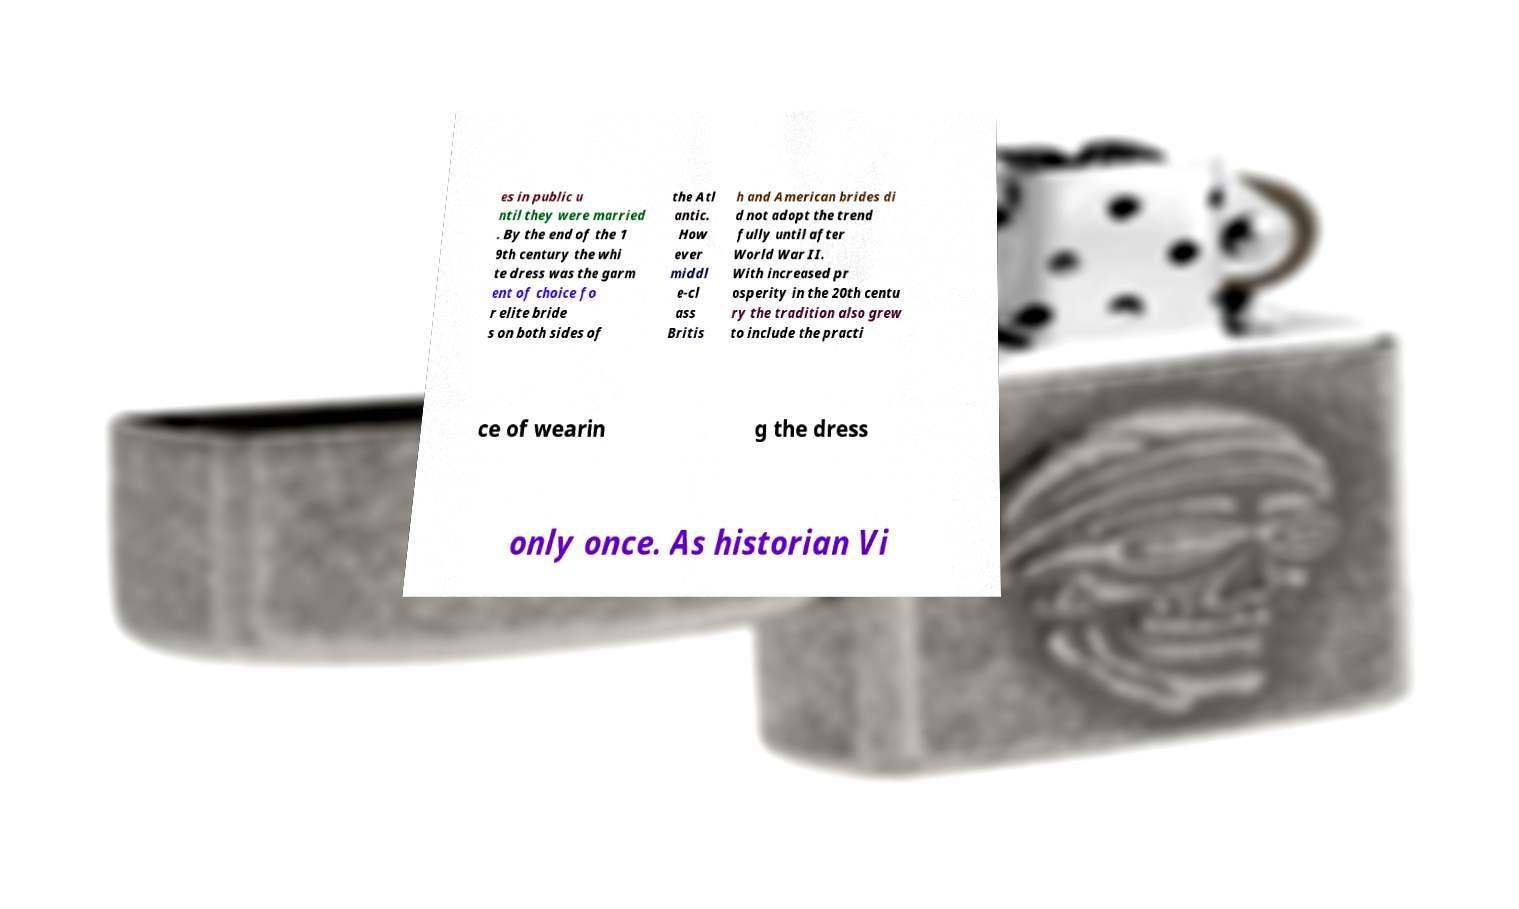Can you read and provide the text displayed in the image?This photo seems to have some interesting text. Can you extract and type it out for me? es in public u ntil they were married . By the end of the 1 9th century the whi te dress was the garm ent of choice fo r elite bride s on both sides of the Atl antic. How ever middl e-cl ass Britis h and American brides di d not adopt the trend fully until after World War II. With increased pr osperity in the 20th centu ry the tradition also grew to include the practi ce of wearin g the dress only once. As historian Vi 